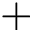Convert formula to latex. <formula><loc_0><loc_0><loc_500><loc_500>+</formula> 